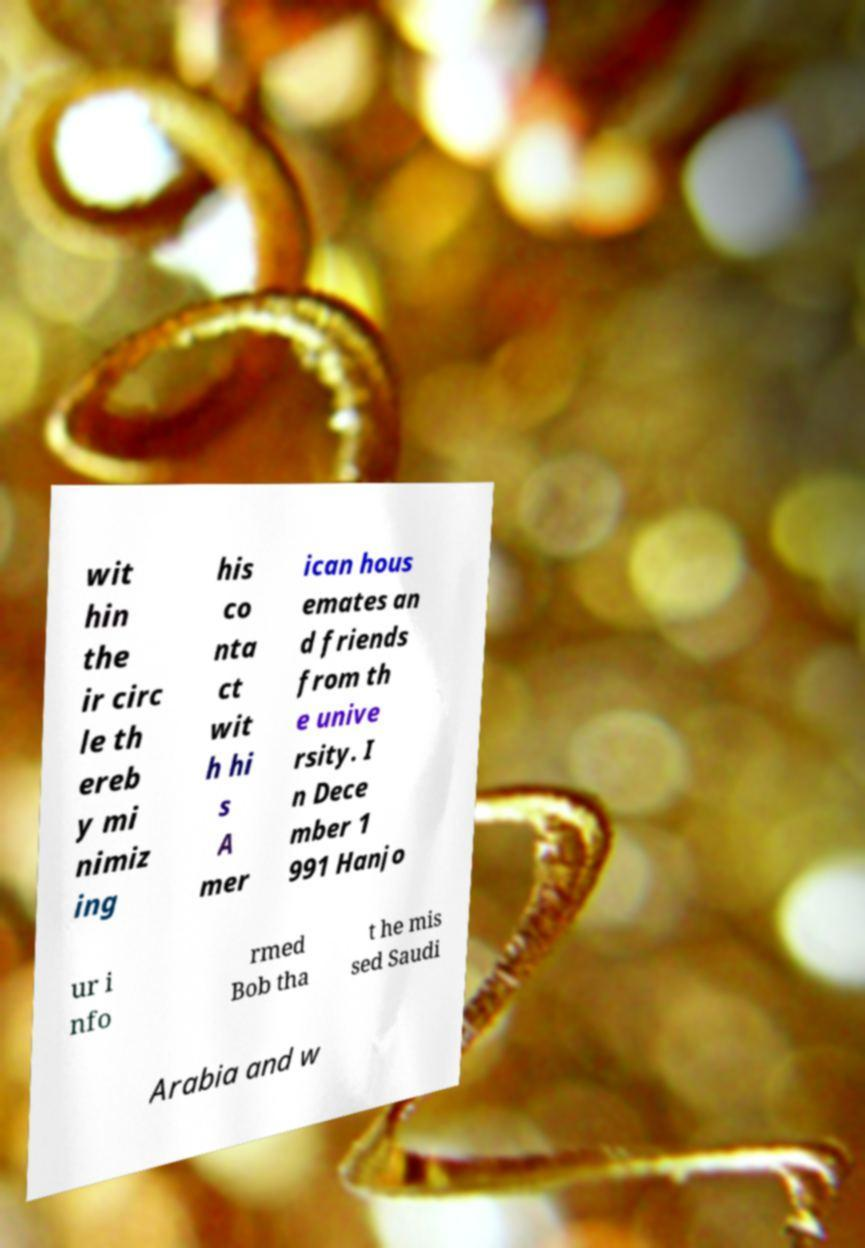Could you assist in decoding the text presented in this image and type it out clearly? wit hin the ir circ le th ereb y mi nimiz ing his co nta ct wit h hi s A mer ican hous emates an d friends from th e unive rsity. I n Dece mber 1 991 Hanjo ur i nfo rmed Bob tha t he mis sed Saudi Arabia and w 